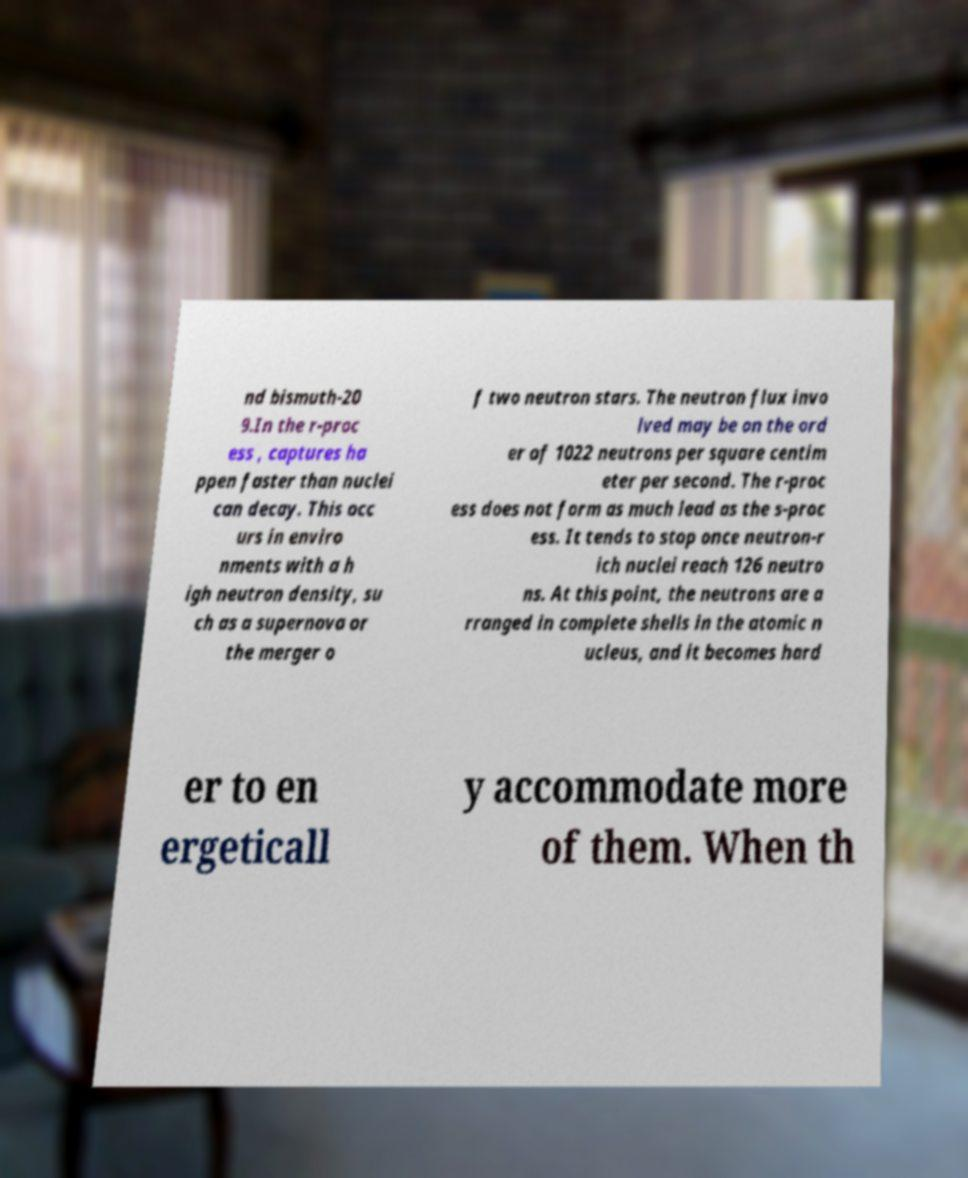Please identify and transcribe the text found in this image. nd bismuth-20 9.In the r-proc ess , captures ha ppen faster than nuclei can decay. This occ urs in enviro nments with a h igh neutron density, su ch as a supernova or the merger o f two neutron stars. The neutron flux invo lved may be on the ord er of 1022 neutrons per square centim eter per second. The r-proc ess does not form as much lead as the s-proc ess. It tends to stop once neutron-r ich nuclei reach 126 neutro ns. At this point, the neutrons are a rranged in complete shells in the atomic n ucleus, and it becomes hard er to en ergeticall y accommodate more of them. When th 